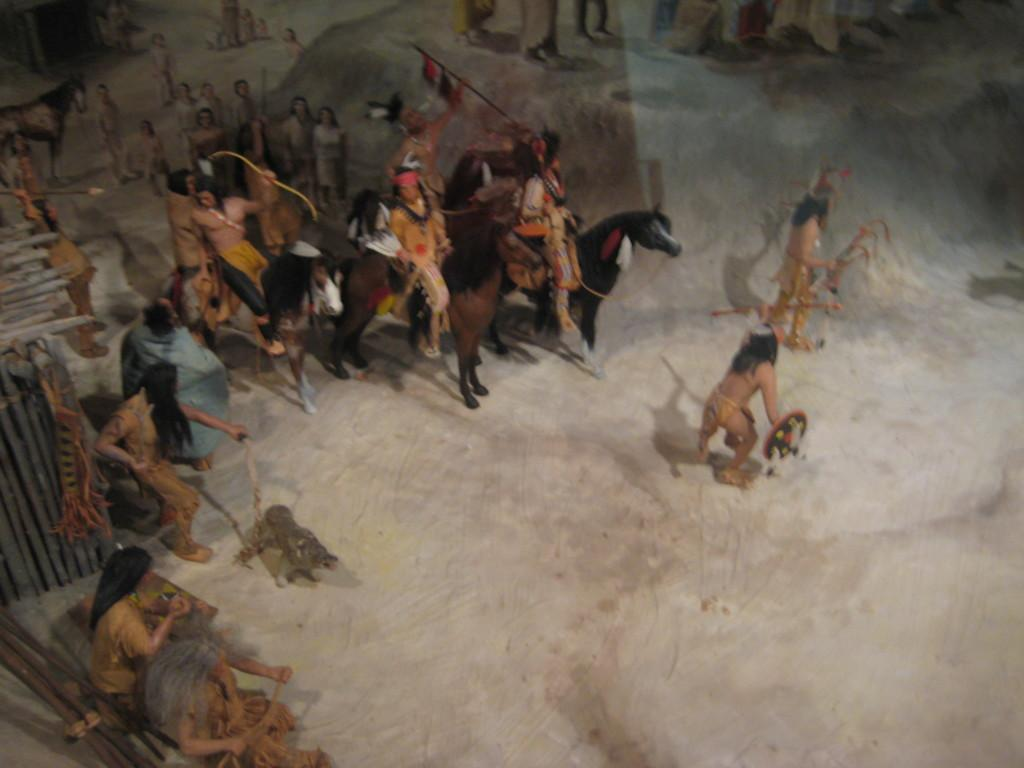What is the nature of the image? The image is a depiction. How many people are present in the image? There are multiple people in the image. What are some of the people doing in the image? Some people are sitting on horses, and some are holding things in their hands. What type of box is being used for religious purposes in the image? There is no box or religious activity present in the image. What type of nut is being held by the person on the horse in the image? There is no nut present in the image; people are holding unspecified things in their hands. 